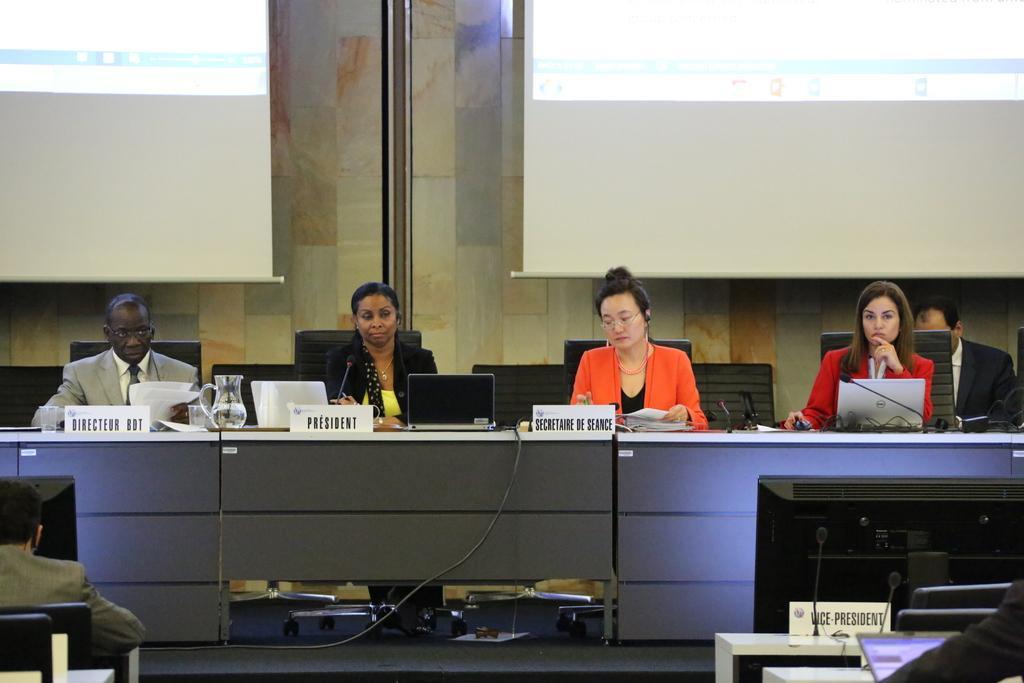In one or two sentences, can you explain what this image depicts? In this image, few peoples are sat on the chair. There are few items are placed on desk. That is placed in-front of them. And back side, we can see a wall, 2 screens. And microphones on the top of the table. 